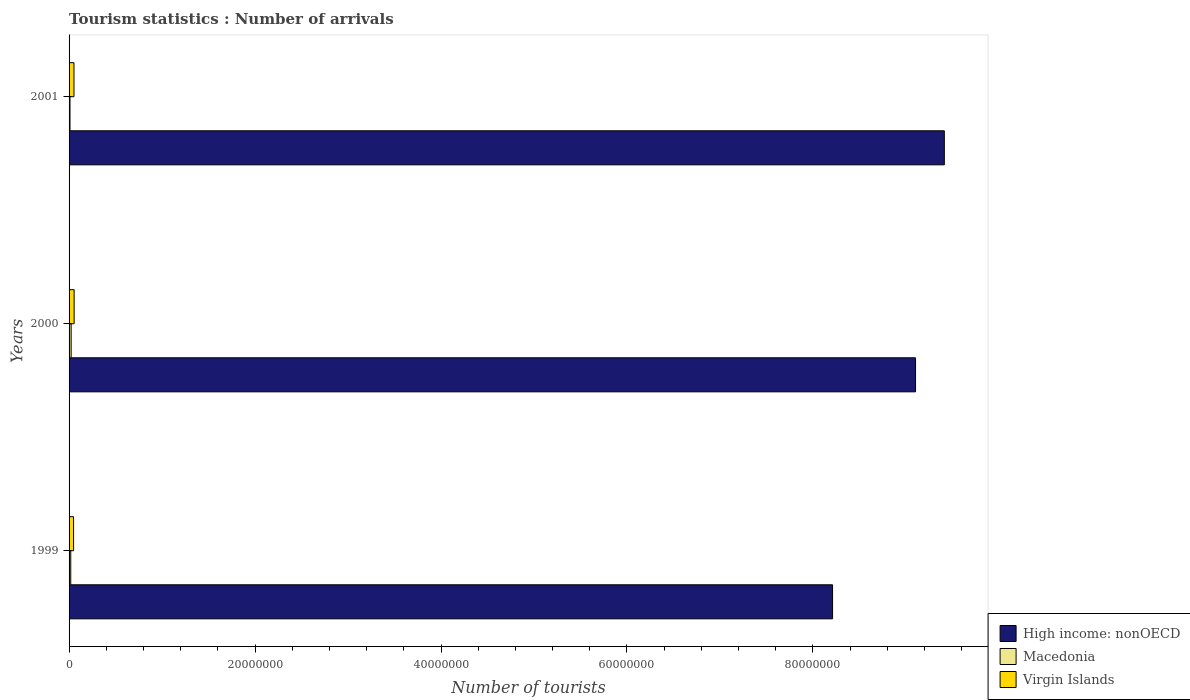How many different coloured bars are there?
Provide a short and direct response. 3. How many groups of bars are there?
Your answer should be very brief. 3. Are the number of bars on each tick of the Y-axis equal?
Provide a succinct answer. Yes. How many bars are there on the 3rd tick from the bottom?
Give a very brief answer. 3. What is the number of tourist arrivals in Macedonia in 2001?
Your response must be concise. 9.90e+04. Across all years, what is the maximum number of tourist arrivals in Virgin Islands?
Offer a very short reply. 5.46e+05. Across all years, what is the minimum number of tourist arrivals in High income: nonOECD?
Ensure brevity in your answer.  8.21e+07. What is the total number of tourist arrivals in Virgin Islands in the graph?
Provide a short and direct response. 1.56e+06. What is the difference between the number of tourist arrivals in Macedonia in 1999 and that in 2000?
Give a very brief answer. -4.30e+04. What is the difference between the number of tourist arrivals in High income: nonOECD in 2001 and the number of tourist arrivals in Virgin Islands in 1999?
Provide a short and direct response. 9.36e+07. What is the average number of tourist arrivals in High income: nonOECD per year?
Your response must be concise. 8.91e+07. In the year 2000, what is the difference between the number of tourist arrivals in Macedonia and number of tourist arrivals in High income: nonOECD?
Your response must be concise. -9.08e+07. What is the ratio of the number of tourist arrivals in Macedonia in 1999 to that in 2001?
Give a very brief answer. 1.83. Is the number of tourist arrivals in Virgin Islands in 1999 less than that in 2000?
Provide a short and direct response. Yes. What is the difference between the highest and the second highest number of tourist arrivals in Virgin Islands?
Give a very brief answer. 1.90e+04. What is the difference between the highest and the lowest number of tourist arrivals in Virgin Islands?
Your answer should be very brief. 6.20e+04. What does the 1st bar from the top in 1999 represents?
Make the answer very short. Virgin Islands. What does the 3rd bar from the bottom in 2001 represents?
Offer a terse response. Virgin Islands. How many years are there in the graph?
Provide a short and direct response. 3. What is the difference between two consecutive major ticks on the X-axis?
Provide a short and direct response. 2.00e+07. Does the graph contain grids?
Give a very brief answer. No. Where does the legend appear in the graph?
Your answer should be very brief. Bottom right. How many legend labels are there?
Your response must be concise. 3. How are the legend labels stacked?
Your answer should be very brief. Vertical. What is the title of the graph?
Provide a succinct answer. Tourism statistics : Number of arrivals. Does "Ukraine" appear as one of the legend labels in the graph?
Give a very brief answer. No. What is the label or title of the X-axis?
Make the answer very short. Number of tourists. What is the Number of tourists of High income: nonOECD in 1999?
Give a very brief answer. 8.21e+07. What is the Number of tourists of Macedonia in 1999?
Offer a very short reply. 1.81e+05. What is the Number of tourists in Virgin Islands in 1999?
Offer a terse response. 4.84e+05. What is the Number of tourists in High income: nonOECD in 2000?
Offer a very short reply. 9.10e+07. What is the Number of tourists in Macedonia in 2000?
Provide a short and direct response. 2.24e+05. What is the Number of tourists of Virgin Islands in 2000?
Provide a short and direct response. 5.46e+05. What is the Number of tourists of High income: nonOECD in 2001?
Your answer should be compact. 9.41e+07. What is the Number of tourists of Macedonia in 2001?
Offer a very short reply. 9.90e+04. What is the Number of tourists of Virgin Islands in 2001?
Offer a terse response. 5.27e+05. Across all years, what is the maximum Number of tourists in High income: nonOECD?
Make the answer very short. 9.41e+07. Across all years, what is the maximum Number of tourists in Macedonia?
Provide a short and direct response. 2.24e+05. Across all years, what is the maximum Number of tourists of Virgin Islands?
Your answer should be compact. 5.46e+05. Across all years, what is the minimum Number of tourists in High income: nonOECD?
Your response must be concise. 8.21e+07. Across all years, what is the minimum Number of tourists in Macedonia?
Make the answer very short. 9.90e+04. Across all years, what is the minimum Number of tourists of Virgin Islands?
Your answer should be very brief. 4.84e+05. What is the total Number of tourists in High income: nonOECD in the graph?
Offer a terse response. 2.67e+08. What is the total Number of tourists of Macedonia in the graph?
Ensure brevity in your answer.  5.04e+05. What is the total Number of tourists in Virgin Islands in the graph?
Give a very brief answer. 1.56e+06. What is the difference between the Number of tourists in High income: nonOECD in 1999 and that in 2000?
Provide a short and direct response. -8.92e+06. What is the difference between the Number of tourists in Macedonia in 1999 and that in 2000?
Give a very brief answer. -4.30e+04. What is the difference between the Number of tourists in Virgin Islands in 1999 and that in 2000?
Give a very brief answer. -6.20e+04. What is the difference between the Number of tourists of High income: nonOECD in 1999 and that in 2001?
Your answer should be very brief. -1.20e+07. What is the difference between the Number of tourists of Macedonia in 1999 and that in 2001?
Make the answer very short. 8.20e+04. What is the difference between the Number of tourists of Virgin Islands in 1999 and that in 2001?
Offer a very short reply. -4.30e+04. What is the difference between the Number of tourists in High income: nonOECD in 2000 and that in 2001?
Your answer should be very brief. -3.10e+06. What is the difference between the Number of tourists of Macedonia in 2000 and that in 2001?
Provide a succinct answer. 1.25e+05. What is the difference between the Number of tourists of Virgin Islands in 2000 and that in 2001?
Your answer should be compact. 1.90e+04. What is the difference between the Number of tourists in High income: nonOECD in 1999 and the Number of tourists in Macedonia in 2000?
Ensure brevity in your answer.  8.19e+07. What is the difference between the Number of tourists of High income: nonOECD in 1999 and the Number of tourists of Virgin Islands in 2000?
Provide a succinct answer. 8.16e+07. What is the difference between the Number of tourists in Macedonia in 1999 and the Number of tourists in Virgin Islands in 2000?
Your answer should be compact. -3.65e+05. What is the difference between the Number of tourists in High income: nonOECD in 1999 and the Number of tourists in Macedonia in 2001?
Your answer should be compact. 8.20e+07. What is the difference between the Number of tourists in High income: nonOECD in 1999 and the Number of tourists in Virgin Islands in 2001?
Provide a short and direct response. 8.16e+07. What is the difference between the Number of tourists in Macedonia in 1999 and the Number of tourists in Virgin Islands in 2001?
Your answer should be very brief. -3.46e+05. What is the difference between the Number of tourists in High income: nonOECD in 2000 and the Number of tourists in Macedonia in 2001?
Provide a short and direct response. 9.09e+07. What is the difference between the Number of tourists in High income: nonOECD in 2000 and the Number of tourists in Virgin Islands in 2001?
Give a very brief answer. 9.05e+07. What is the difference between the Number of tourists of Macedonia in 2000 and the Number of tourists of Virgin Islands in 2001?
Offer a very short reply. -3.03e+05. What is the average Number of tourists of High income: nonOECD per year?
Your response must be concise. 8.91e+07. What is the average Number of tourists in Macedonia per year?
Your answer should be very brief. 1.68e+05. What is the average Number of tourists in Virgin Islands per year?
Offer a very short reply. 5.19e+05. In the year 1999, what is the difference between the Number of tourists of High income: nonOECD and Number of tourists of Macedonia?
Give a very brief answer. 8.19e+07. In the year 1999, what is the difference between the Number of tourists of High income: nonOECD and Number of tourists of Virgin Islands?
Offer a very short reply. 8.16e+07. In the year 1999, what is the difference between the Number of tourists of Macedonia and Number of tourists of Virgin Islands?
Your answer should be compact. -3.03e+05. In the year 2000, what is the difference between the Number of tourists in High income: nonOECD and Number of tourists in Macedonia?
Your answer should be very brief. 9.08e+07. In the year 2000, what is the difference between the Number of tourists of High income: nonOECD and Number of tourists of Virgin Islands?
Make the answer very short. 9.05e+07. In the year 2000, what is the difference between the Number of tourists of Macedonia and Number of tourists of Virgin Islands?
Offer a terse response. -3.22e+05. In the year 2001, what is the difference between the Number of tourists in High income: nonOECD and Number of tourists in Macedonia?
Give a very brief answer. 9.40e+07. In the year 2001, what is the difference between the Number of tourists of High income: nonOECD and Number of tourists of Virgin Islands?
Keep it short and to the point. 9.36e+07. In the year 2001, what is the difference between the Number of tourists of Macedonia and Number of tourists of Virgin Islands?
Make the answer very short. -4.28e+05. What is the ratio of the Number of tourists of High income: nonOECD in 1999 to that in 2000?
Make the answer very short. 0.9. What is the ratio of the Number of tourists in Macedonia in 1999 to that in 2000?
Your answer should be compact. 0.81. What is the ratio of the Number of tourists of Virgin Islands in 1999 to that in 2000?
Make the answer very short. 0.89. What is the ratio of the Number of tourists in High income: nonOECD in 1999 to that in 2001?
Your answer should be very brief. 0.87. What is the ratio of the Number of tourists in Macedonia in 1999 to that in 2001?
Make the answer very short. 1.83. What is the ratio of the Number of tourists of Virgin Islands in 1999 to that in 2001?
Provide a short and direct response. 0.92. What is the ratio of the Number of tourists in High income: nonOECD in 2000 to that in 2001?
Make the answer very short. 0.97. What is the ratio of the Number of tourists of Macedonia in 2000 to that in 2001?
Ensure brevity in your answer.  2.26. What is the ratio of the Number of tourists of Virgin Islands in 2000 to that in 2001?
Give a very brief answer. 1.04. What is the difference between the highest and the second highest Number of tourists of High income: nonOECD?
Provide a short and direct response. 3.10e+06. What is the difference between the highest and the second highest Number of tourists of Macedonia?
Provide a succinct answer. 4.30e+04. What is the difference between the highest and the second highest Number of tourists of Virgin Islands?
Make the answer very short. 1.90e+04. What is the difference between the highest and the lowest Number of tourists of High income: nonOECD?
Your answer should be compact. 1.20e+07. What is the difference between the highest and the lowest Number of tourists in Macedonia?
Offer a very short reply. 1.25e+05. What is the difference between the highest and the lowest Number of tourists in Virgin Islands?
Ensure brevity in your answer.  6.20e+04. 